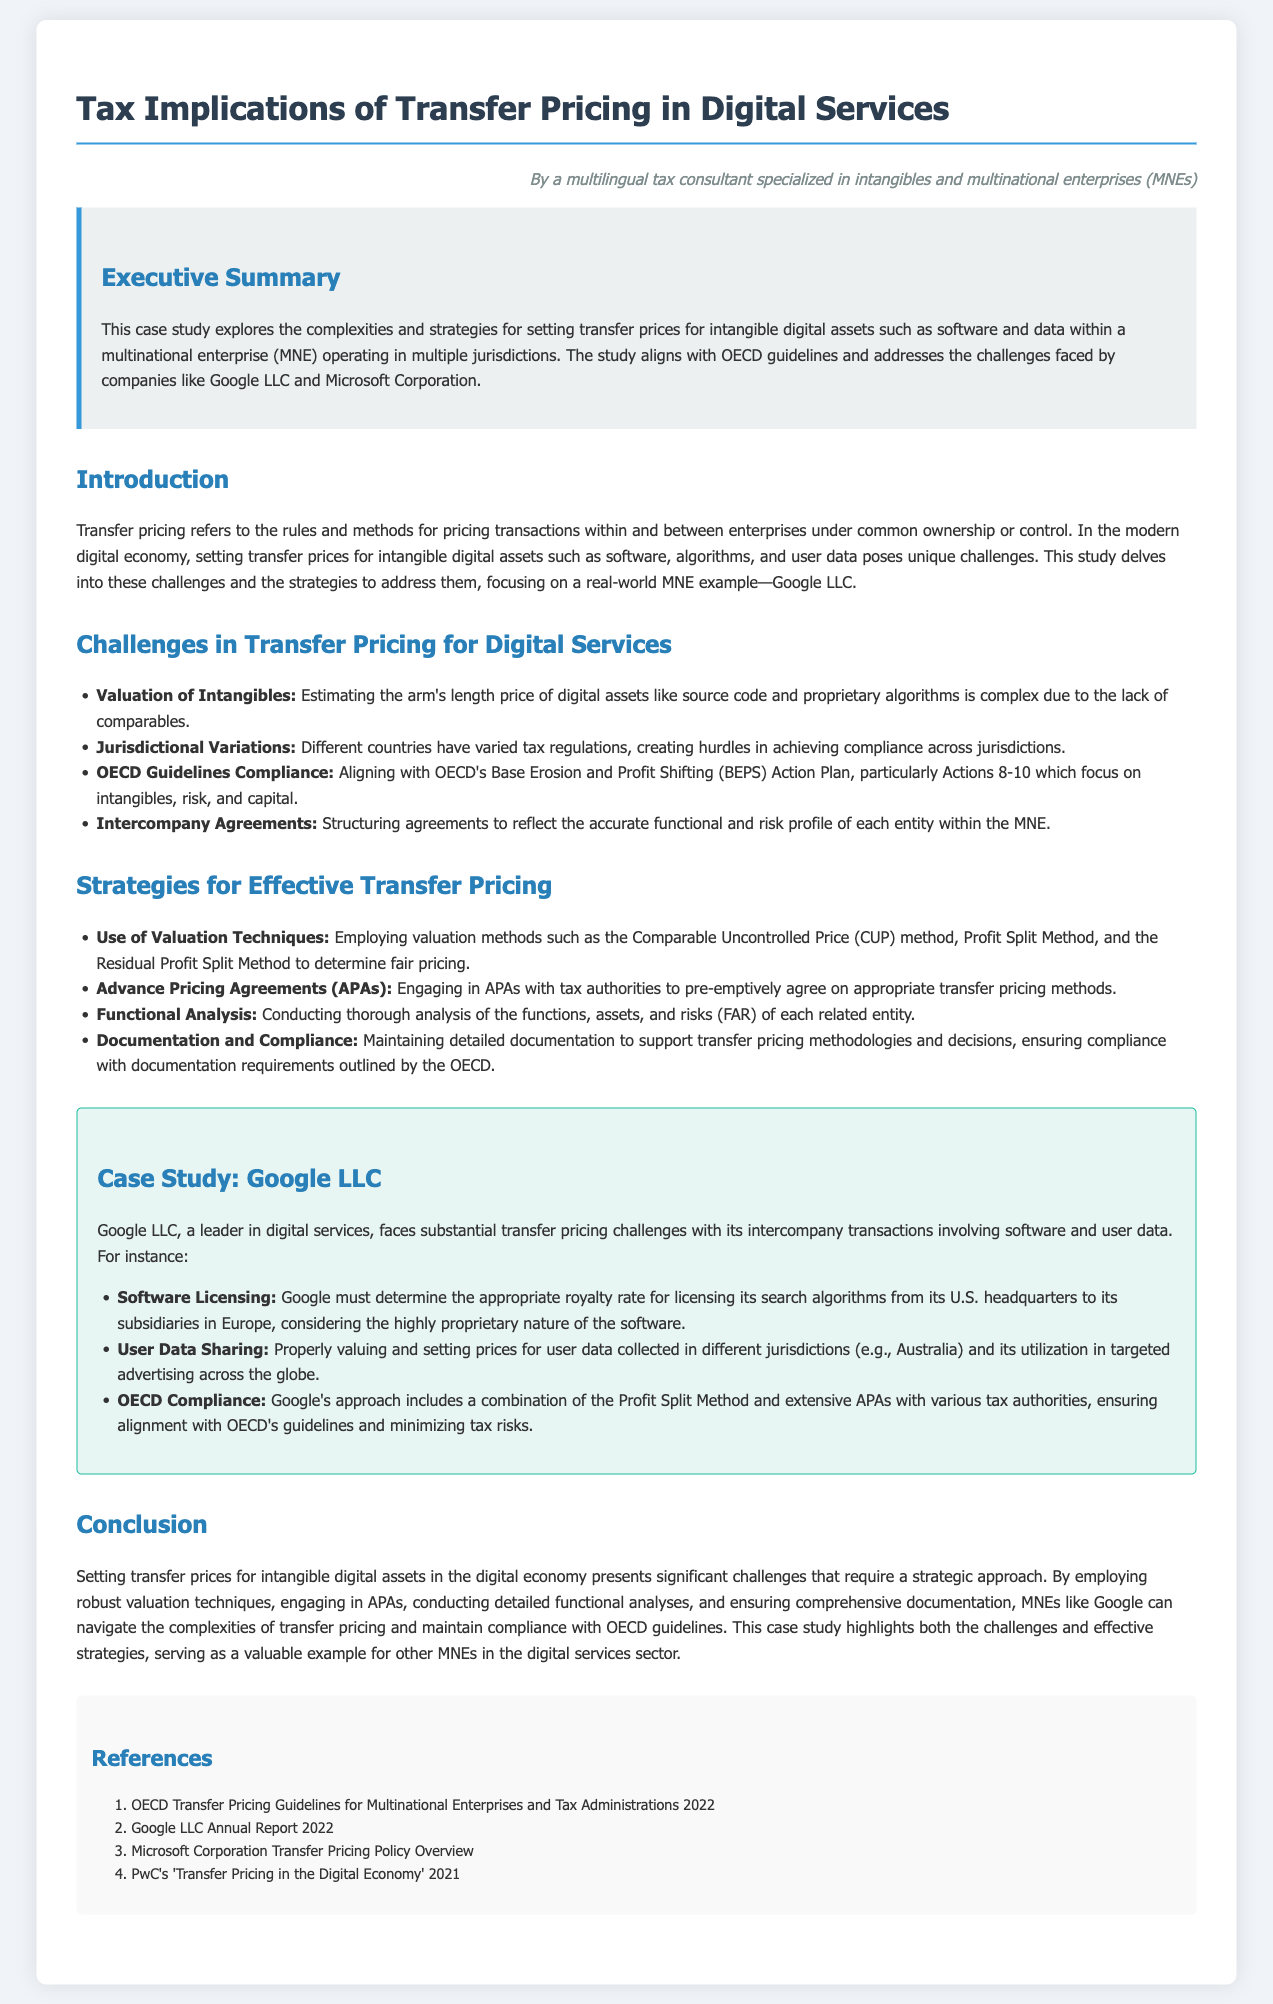what is the focus of the case study? The case study explores the complexities and strategies for setting transfer prices for intangible digital assets within an MNE, aligning with OECD guidelines.
Answer: transfer prices for intangible digital assets what are the main challenges mentioned in transfer pricing for digital services? The document lists several challenges, including valuation of intangibles and jurisdictional variations.
Answer: valuation of intangibles, jurisdictional variations which method does Google LLC use for compliance with OECD guidelines? The case study mentions Google’s use of the Profit Split Method and extensive APAs with various tax authorities for compliance.
Answer: Profit Split Method what year is referenced in the Google LLC Annual Report in the references? The references section lists the year of the report as 2022.
Answer: 2022 what is the purpose of Advance Pricing Agreements (APAs)? The document states that APAs are engaged to pre-emptively agree on appropriate transfer pricing methods with tax authorities.
Answer: agree on appropriate transfer pricing methods how does the case study highlight the digital economy's impact on transfer pricing? The study emphasizes that setting transfer prices for intangible digital assets presents significant challenges requiring strategic approaches.
Answer: significant challenges requiring strategic approaches what guideline does the case study align with? The case study is aligned with the OECD's base erosion and profit shifting guidelines, particularly Actions 8-10.
Answer: OECD guidelines which two MNEs are mentioned as examples in the case study? The document references Google LLC and Microsoft Corporation as examples of MNEs facing transfer pricing challenges.
Answer: Google LLC and Microsoft Corporation 